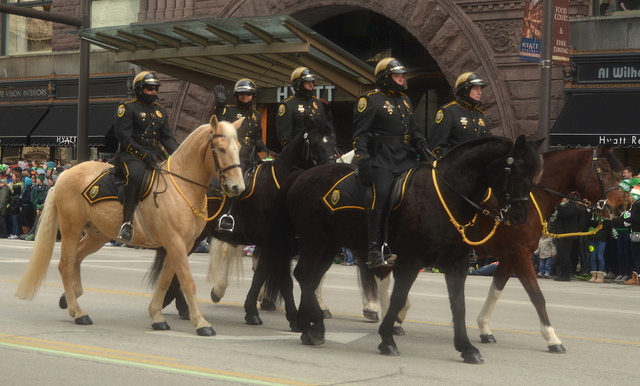Please transcribe the text information in this image. AI With 1000 1000 R 